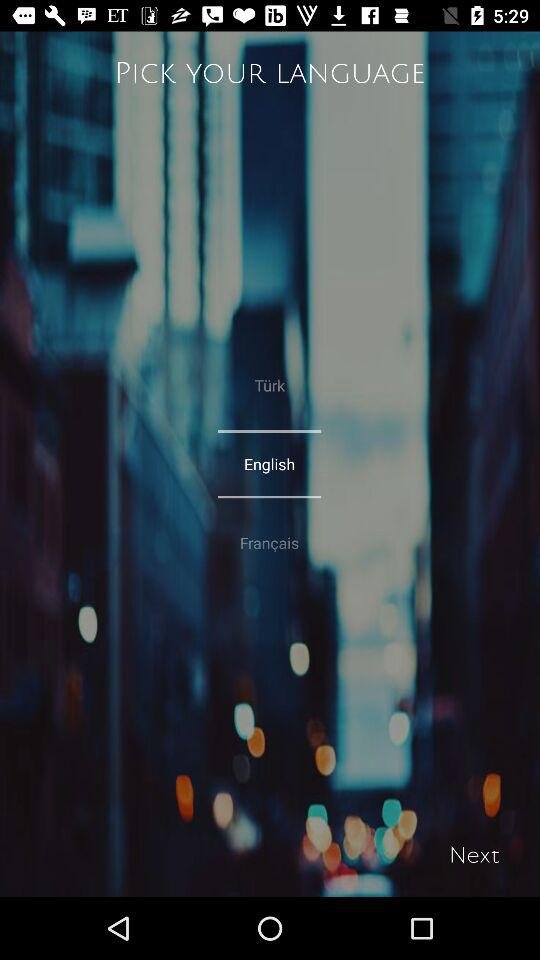How many languages are available on this screen?
Answer the question using a single word or phrase. 3 